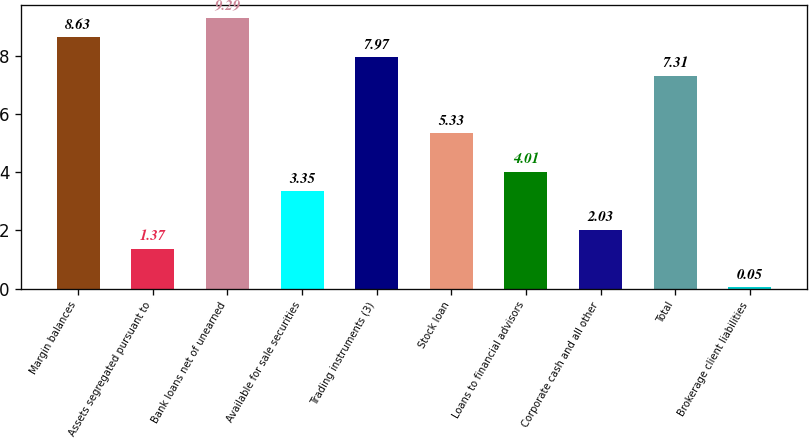Convert chart. <chart><loc_0><loc_0><loc_500><loc_500><bar_chart><fcel>Margin balances<fcel>Assets segregated pursuant to<fcel>Bank loans net of unearned<fcel>Available for sale securities<fcel>Trading instruments (3)<fcel>Stock loan<fcel>Loans to financial advisors<fcel>Corporate cash and all other<fcel>Total<fcel>Brokerage client liabilities<nl><fcel>8.63<fcel>1.37<fcel>9.29<fcel>3.35<fcel>7.97<fcel>5.33<fcel>4.01<fcel>2.03<fcel>7.31<fcel>0.05<nl></chart> 